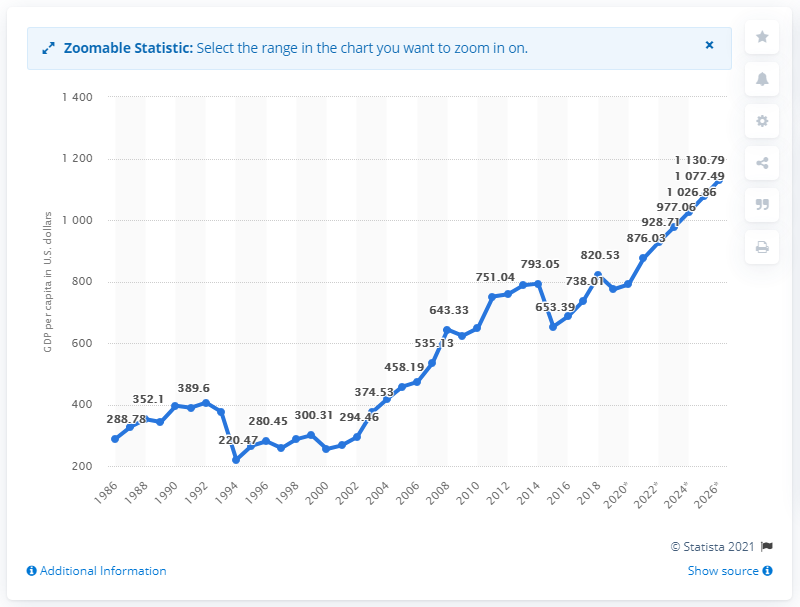Draw attention to some important aspects in this diagram. In 2019, the GDP per capita in Burkina Faso was 774.87. 